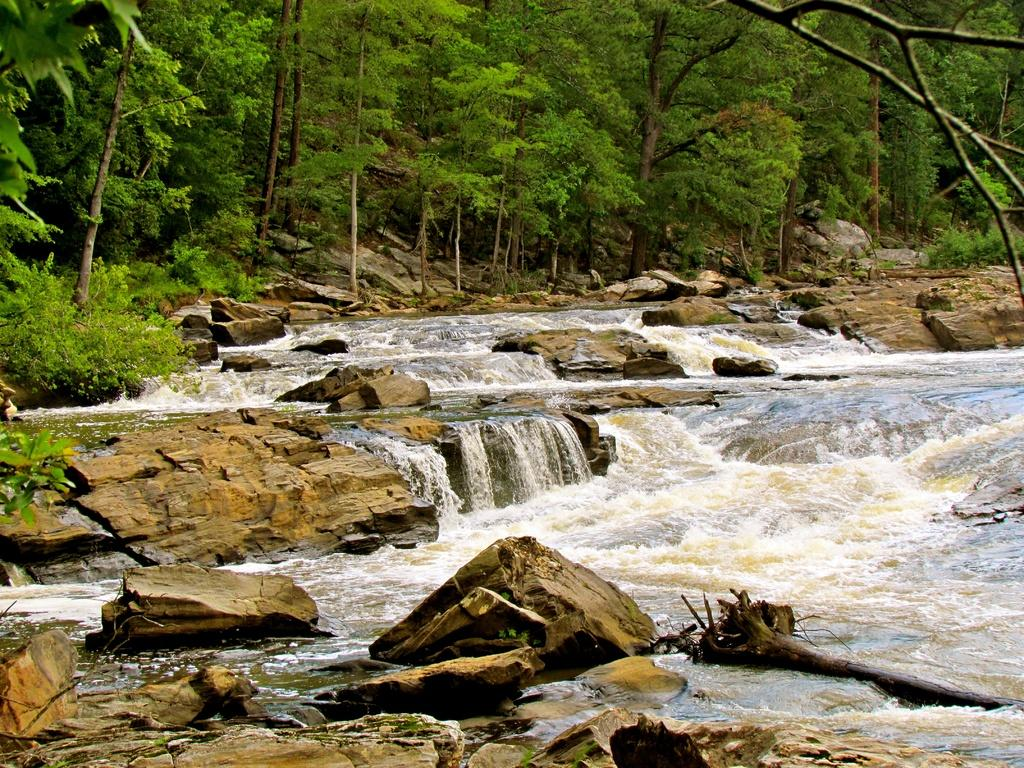What is the primary element flowing in the image? There is water flowing in the image. What can be seen at the bottom of the image? Rocks are present at the bottom of the image. What type of vegetation is visible in the background of the image? There are trees in the background of the image. What type of environment might the image be taken in? The image appears to be taken in a forest. Can you see a toad hopping on the stage in the image? There is no stage or toad present in the image; it features water flowing over rocks with trees in the background. 